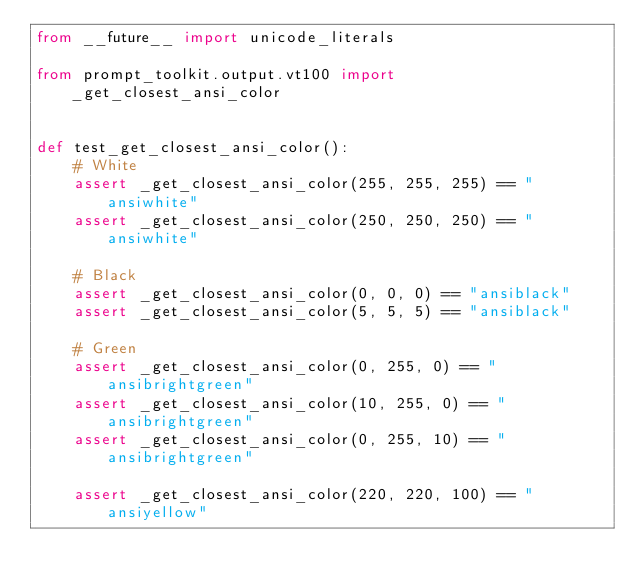Convert code to text. <code><loc_0><loc_0><loc_500><loc_500><_Python_>from __future__ import unicode_literals

from prompt_toolkit.output.vt100 import _get_closest_ansi_color


def test_get_closest_ansi_color():
    # White
    assert _get_closest_ansi_color(255, 255, 255) == "ansiwhite"
    assert _get_closest_ansi_color(250, 250, 250) == "ansiwhite"

    # Black
    assert _get_closest_ansi_color(0, 0, 0) == "ansiblack"
    assert _get_closest_ansi_color(5, 5, 5) == "ansiblack"

    # Green
    assert _get_closest_ansi_color(0, 255, 0) == "ansibrightgreen"
    assert _get_closest_ansi_color(10, 255, 0) == "ansibrightgreen"
    assert _get_closest_ansi_color(0, 255, 10) == "ansibrightgreen"

    assert _get_closest_ansi_color(220, 220, 100) == "ansiyellow"
</code> 